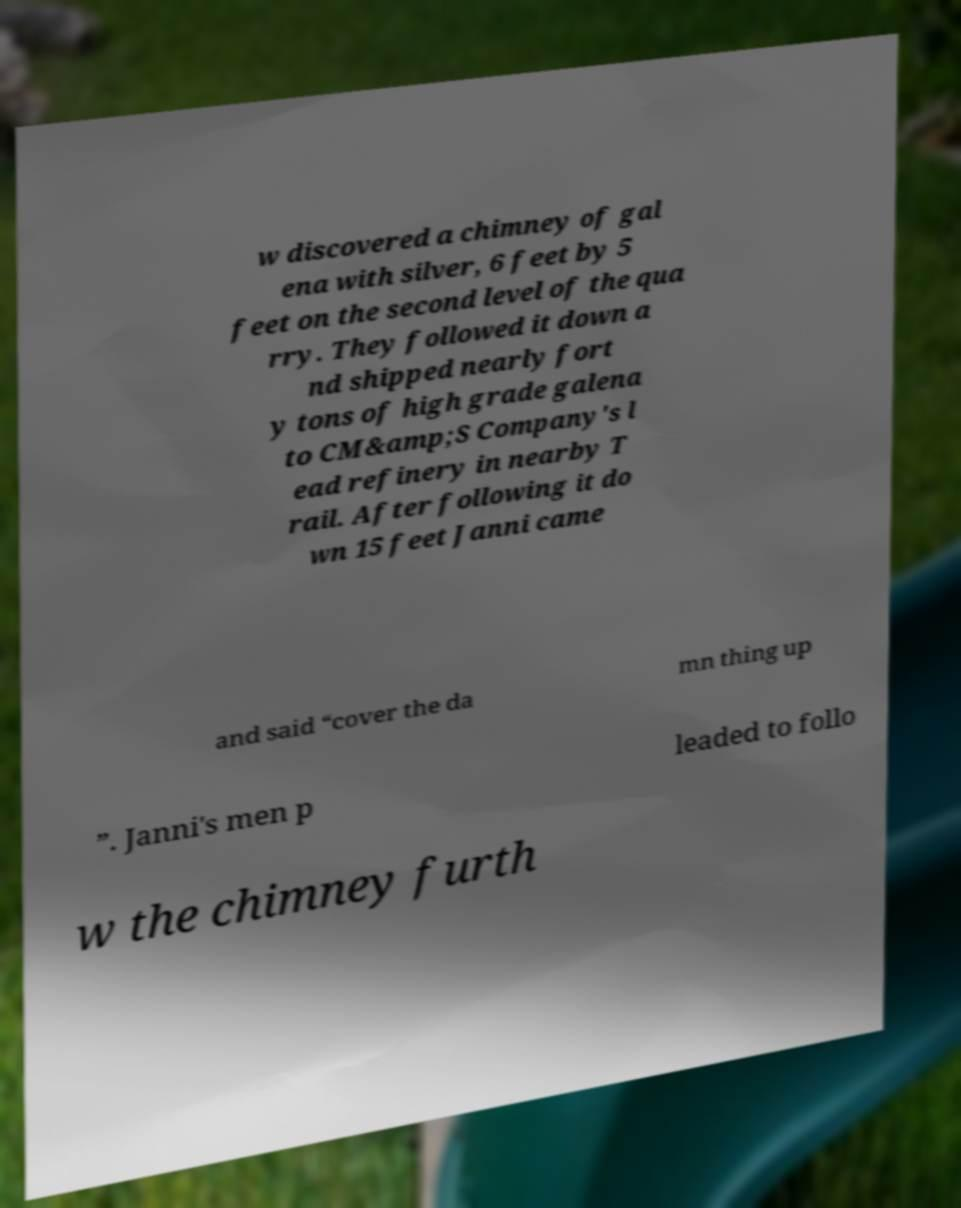Could you assist in decoding the text presented in this image and type it out clearly? w discovered a chimney of gal ena with silver, 6 feet by 5 feet on the second level of the qua rry. They followed it down a nd shipped nearly fort y tons of high grade galena to CM&amp;S Company's l ead refinery in nearby T rail. After following it do wn 15 feet Janni came and said “cover the da mn thing up ”. Janni's men p leaded to follo w the chimney furth 